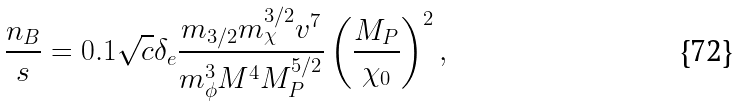Convert formula to latex. <formula><loc_0><loc_0><loc_500><loc_500>\frac { n _ { B } } { s } = 0 . 1 \sqrt { c } \delta _ { e } \frac { m _ { 3 / 2 } m _ { \chi } ^ { 3 / 2 } v ^ { 7 } } { m _ { \phi } ^ { 3 } M ^ { 4 } M _ { P } ^ { 5 / 2 } } \left ( \frac { M _ { P } } { \chi _ { 0 } } \right ) ^ { 2 } ,</formula> 